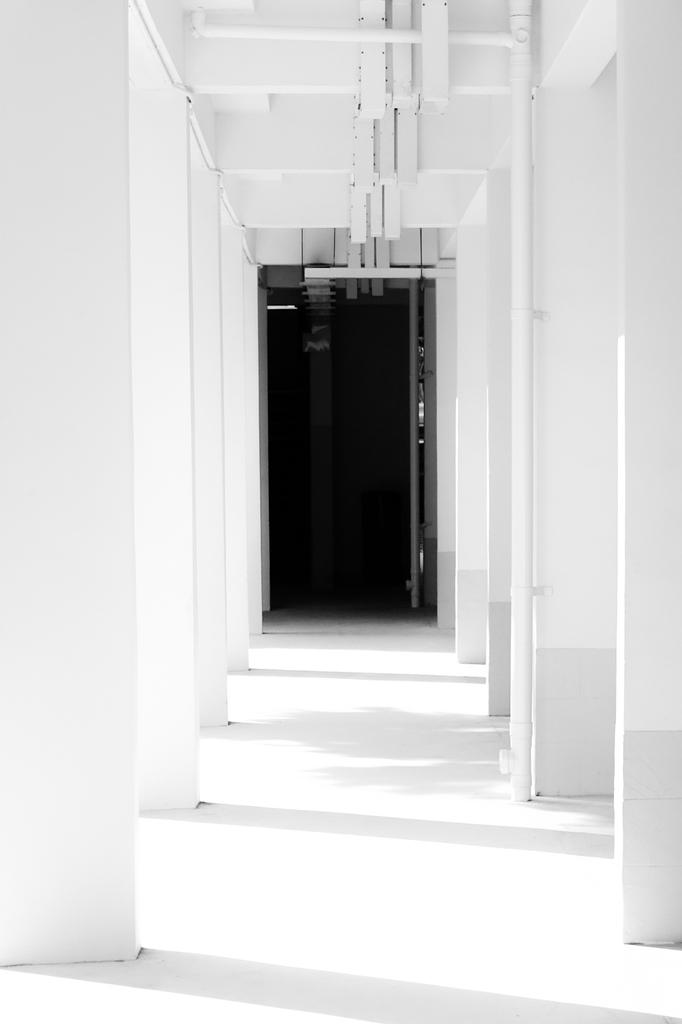What architectural features can be seen in the image? There are pillars in the image. What is the purpose of the pillars in the image? The pillars provide support for the structure. What other feature can be seen in the image? There is a door in the image. What is the function of the door in the image? The door allows access to the structure. Can you see any goldfish swimming in harmony in the image? There are no goldfish or any indication of water in the image. 